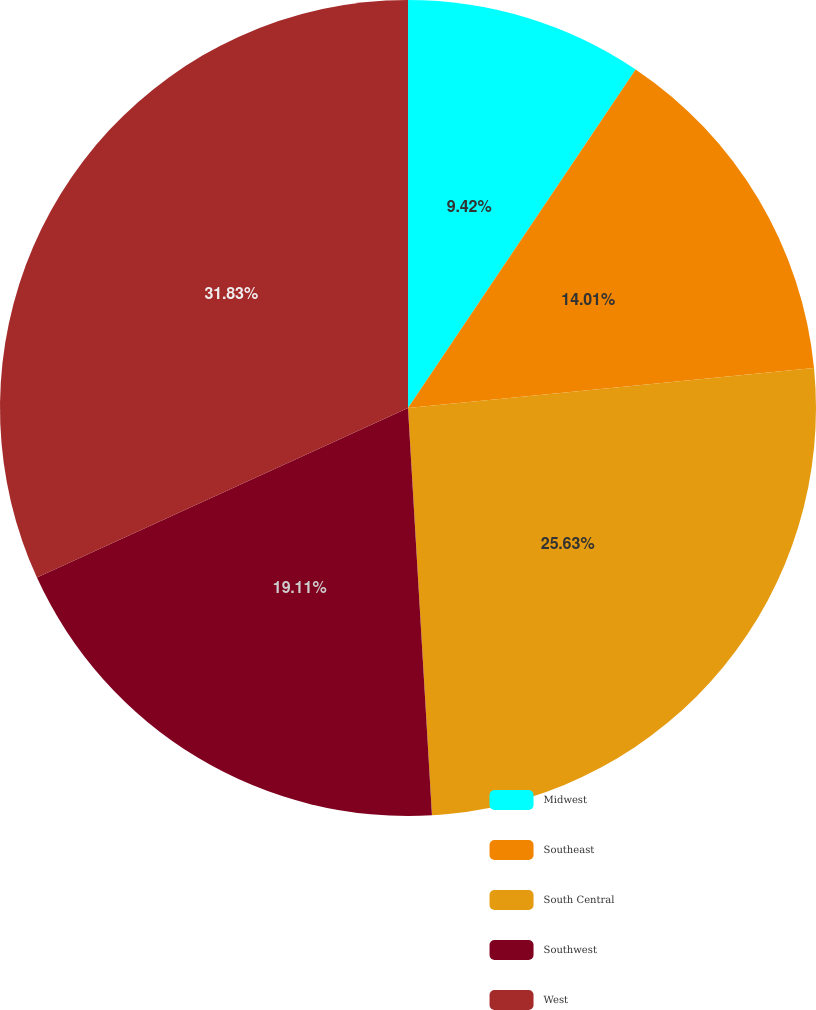Convert chart. <chart><loc_0><loc_0><loc_500><loc_500><pie_chart><fcel>Midwest<fcel>Southeast<fcel>South Central<fcel>Southwest<fcel>West<nl><fcel>9.42%<fcel>14.01%<fcel>25.63%<fcel>19.11%<fcel>31.82%<nl></chart> 